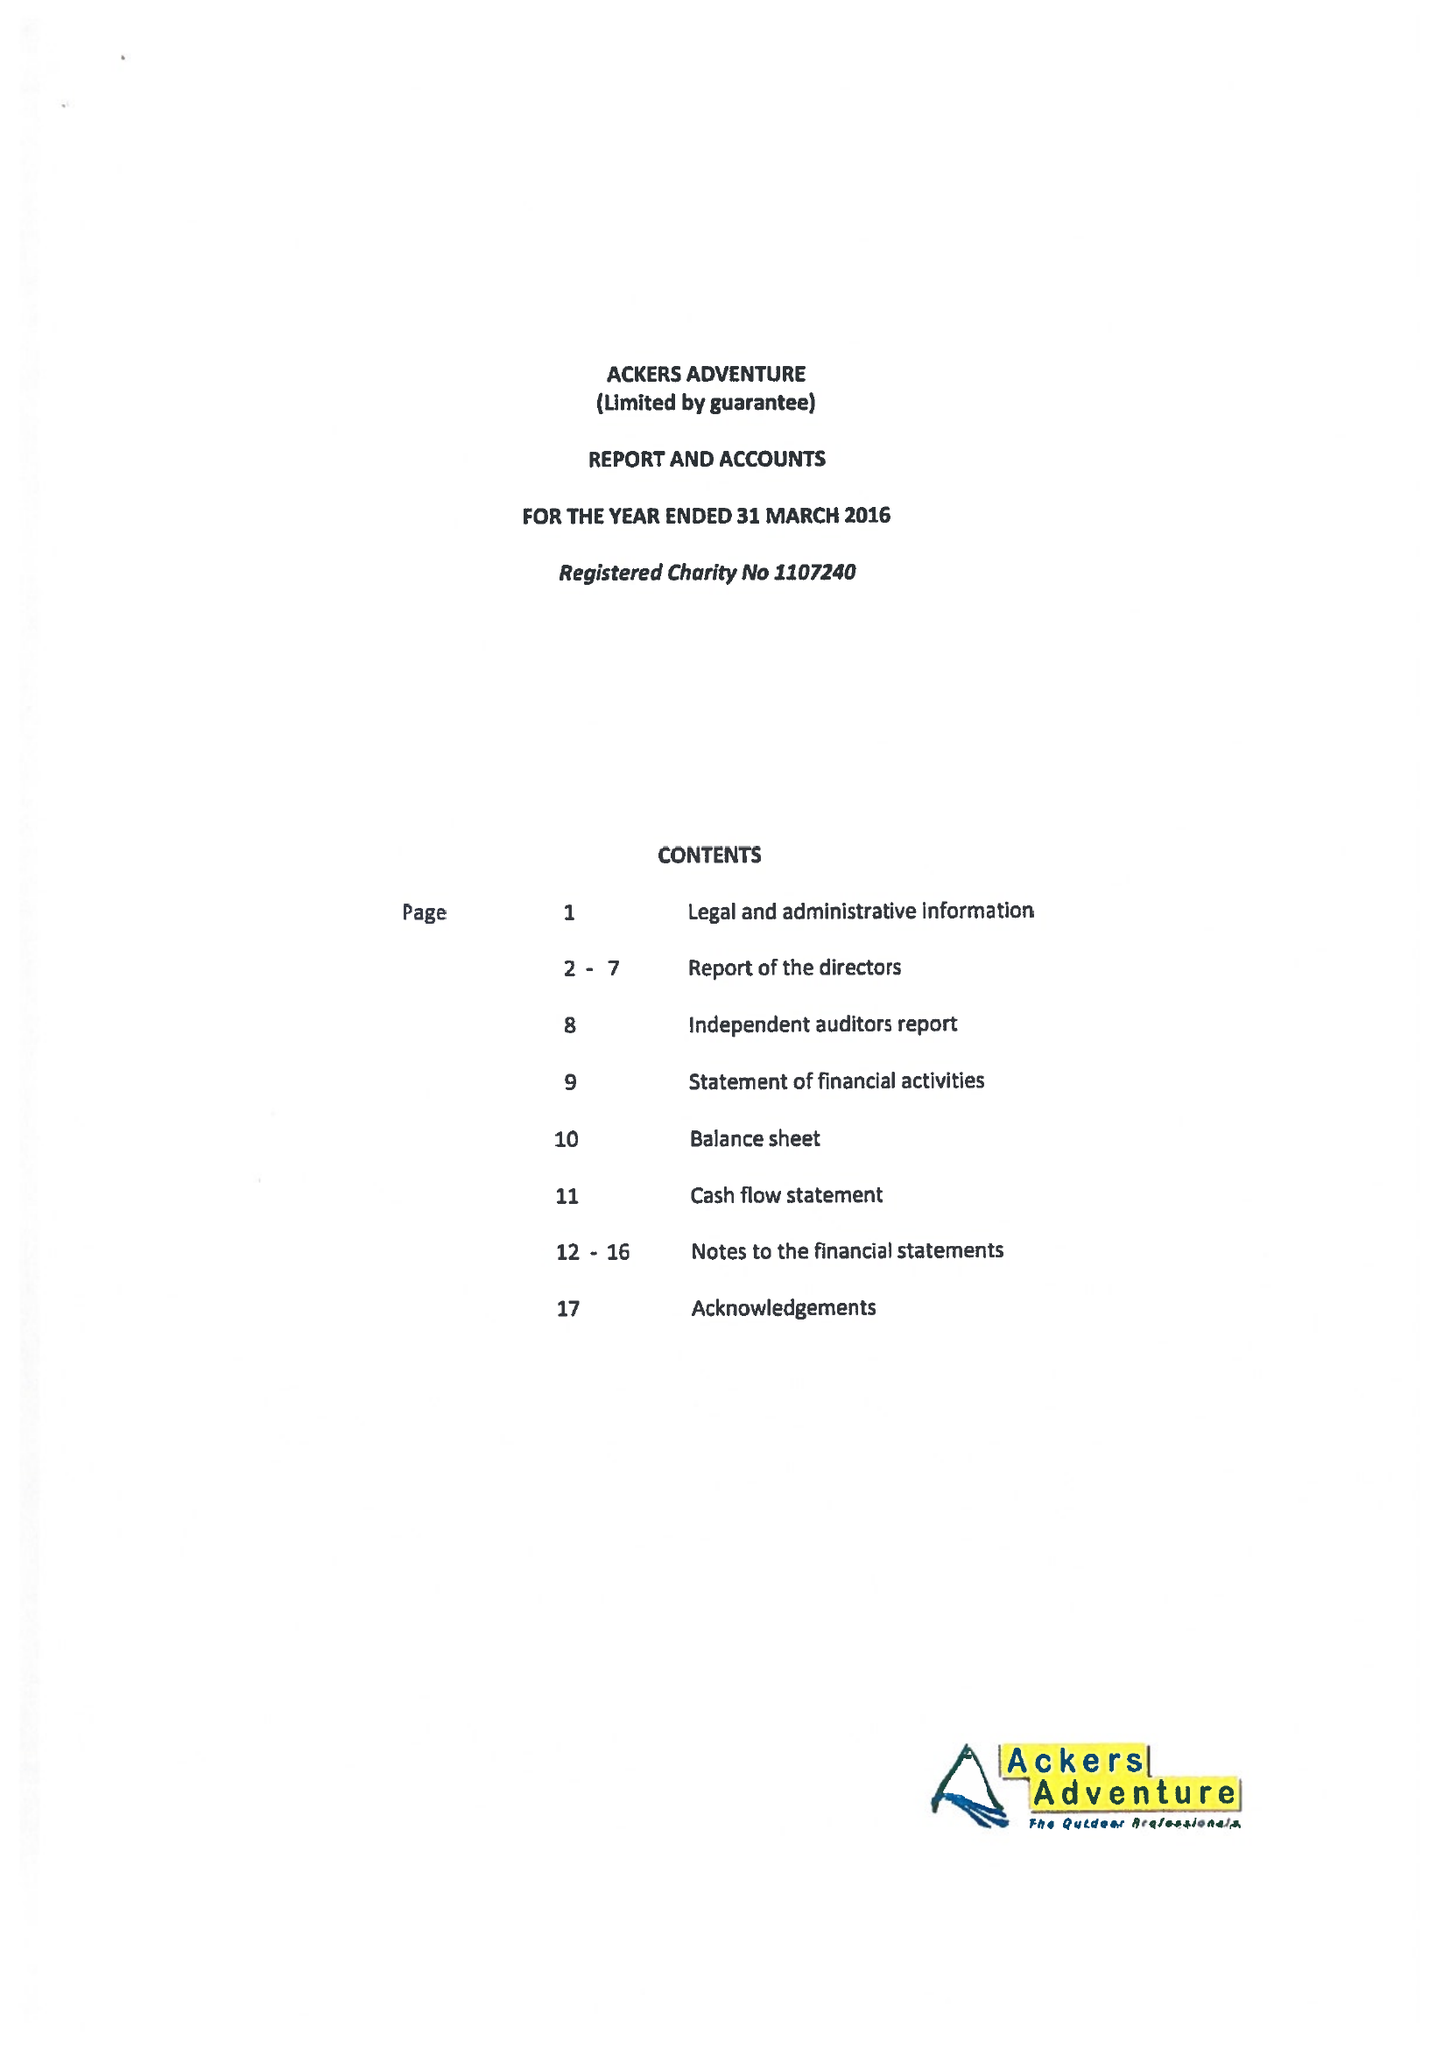What is the value for the report_date?
Answer the question using a single word or phrase. 2016-03-31 